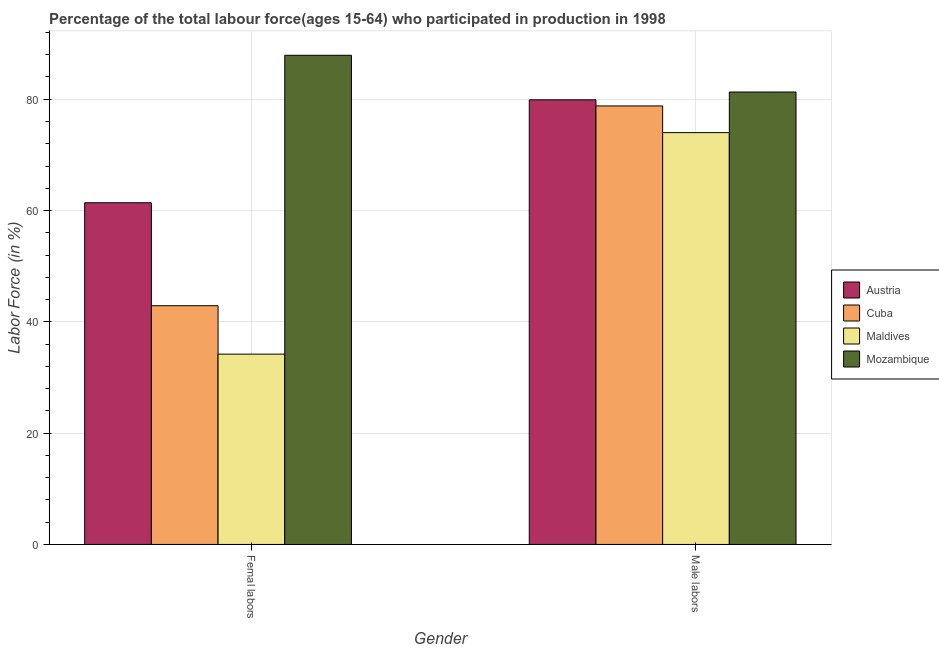Are the number of bars per tick equal to the number of legend labels?
Your response must be concise. Yes. How many bars are there on the 2nd tick from the right?
Your response must be concise. 4. What is the label of the 2nd group of bars from the left?
Offer a very short reply. Male labors. What is the percentage of female labor force in Maldives?
Provide a short and direct response. 34.2. Across all countries, what is the maximum percentage of male labour force?
Provide a short and direct response. 81.3. Across all countries, what is the minimum percentage of male labour force?
Your response must be concise. 74. In which country was the percentage of female labor force maximum?
Ensure brevity in your answer.  Mozambique. In which country was the percentage of female labor force minimum?
Provide a succinct answer. Maldives. What is the total percentage of male labour force in the graph?
Your answer should be compact. 314. What is the difference between the percentage of female labor force in Mozambique and that in Austria?
Ensure brevity in your answer.  26.5. What is the difference between the percentage of male labour force in Mozambique and the percentage of female labor force in Austria?
Make the answer very short. 19.9. What is the average percentage of female labor force per country?
Ensure brevity in your answer.  56.6. What is the difference between the percentage of male labour force and percentage of female labor force in Austria?
Keep it short and to the point. 18.5. In how many countries, is the percentage of male labour force greater than 36 %?
Offer a terse response. 4. What is the ratio of the percentage of male labour force in Mozambique to that in Austria?
Give a very brief answer. 1.02. In how many countries, is the percentage of male labour force greater than the average percentage of male labour force taken over all countries?
Provide a succinct answer. 3. What does the 2nd bar from the left in Male labors represents?
Keep it short and to the point. Cuba. What does the 2nd bar from the right in Femal labors represents?
Provide a succinct answer. Maldives. How many bars are there?
Your answer should be compact. 8. Are all the bars in the graph horizontal?
Your response must be concise. No. What is the difference between two consecutive major ticks on the Y-axis?
Offer a very short reply. 20. Does the graph contain any zero values?
Provide a short and direct response. No. Where does the legend appear in the graph?
Keep it short and to the point. Center right. How are the legend labels stacked?
Your answer should be compact. Vertical. What is the title of the graph?
Your answer should be compact. Percentage of the total labour force(ages 15-64) who participated in production in 1998. Does "Madagascar" appear as one of the legend labels in the graph?
Your response must be concise. No. What is the label or title of the X-axis?
Offer a terse response. Gender. What is the Labor Force (in %) of Austria in Femal labors?
Make the answer very short. 61.4. What is the Labor Force (in %) of Cuba in Femal labors?
Provide a succinct answer. 42.9. What is the Labor Force (in %) in Maldives in Femal labors?
Give a very brief answer. 34.2. What is the Labor Force (in %) of Mozambique in Femal labors?
Provide a succinct answer. 87.9. What is the Labor Force (in %) of Austria in Male labors?
Give a very brief answer. 79.9. What is the Labor Force (in %) of Cuba in Male labors?
Offer a very short reply. 78.8. What is the Labor Force (in %) of Mozambique in Male labors?
Provide a short and direct response. 81.3. Across all Gender, what is the maximum Labor Force (in %) of Austria?
Provide a short and direct response. 79.9. Across all Gender, what is the maximum Labor Force (in %) in Cuba?
Provide a succinct answer. 78.8. Across all Gender, what is the maximum Labor Force (in %) of Maldives?
Keep it short and to the point. 74. Across all Gender, what is the maximum Labor Force (in %) of Mozambique?
Provide a short and direct response. 87.9. Across all Gender, what is the minimum Labor Force (in %) of Austria?
Your answer should be very brief. 61.4. Across all Gender, what is the minimum Labor Force (in %) in Cuba?
Your response must be concise. 42.9. Across all Gender, what is the minimum Labor Force (in %) of Maldives?
Ensure brevity in your answer.  34.2. Across all Gender, what is the minimum Labor Force (in %) in Mozambique?
Your answer should be compact. 81.3. What is the total Labor Force (in %) in Austria in the graph?
Give a very brief answer. 141.3. What is the total Labor Force (in %) in Cuba in the graph?
Your answer should be compact. 121.7. What is the total Labor Force (in %) in Maldives in the graph?
Provide a short and direct response. 108.2. What is the total Labor Force (in %) of Mozambique in the graph?
Provide a short and direct response. 169.2. What is the difference between the Labor Force (in %) in Austria in Femal labors and that in Male labors?
Give a very brief answer. -18.5. What is the difference between the Labor Force (in %) in Cuba in Femal labors and that in Male labors?
Offer a terse response. -35.9. What is the difference between the Labor Force (in %) of Maldives in Femal labors and that in Male labors?
Provide a succinct answer. -39.8. What is the difference between the Labor Force (in %) of Mozambique in Femal labors and that in Male labors?
Offer a very short reply. 6.6. What is the difference between the Labor Force (in %) in Austria in Femal labors and the Labor Force (in %) in Cuba in Male labors?
Your response must be concise. -17.4. What is the difference between the Labor Force (in %) of Austria in Femal labors and the Labor Force (in %) of Mozambique in Male labors?
Your answer should be very brief. -19.9. What is the difference between the Labor Force (in %) in Cuba in Femal labors and the Labor Force (in %) in Maldives in Male labors?
Provide a short and direct response. -31.1. What is the difference between the Labor Force (in %) in Cuba in Femal labors and the Labor Force (in %) in Mozambique in Male labors?
Give a very brief answer. -38.4. What is the difference between the Labor Force (in %) of Maldives in Femal labors and the Labor Force (in %) of Mozambique in Male labors?
Offer a terse response. -47.1. What is the average Labor Force (in %) in Austria per Gender?
Keep it short and to the point. 70.65. What is the average Labor Force (in %) of Cuba per Gender?
Offer a terse response. 60.85. What is the average Labor Force (in %) in Maldives per Gender?
Give a very brief answer. 54.1. What is the average Labor Force (in %) of Mozambique per Gender?
Offer a terse response. 84.6. What is the difference between the Labor Force (in %) of Austria and Labor Force (in %) of Cuba in Femal labors?
Your answer should be compact. 18.5. What is the difference between the Labor Force (in %) of Austria and Labor Force (in %) of Maldives in Femal labors?
Give a very brief answer. 27.2. What is the difference between the Labor Force (in %) of Austria and Labor Force (in %) of Mozambique in Femal labors?
Give a very brief answer. -26.5. What is the difference between the Labor Force (in %) of Cuba and Labor Force (in %) of Maldives in Femal labors?
Offer a terse response. 8.7. What is the difference between the Labor Force (in %) of Cuba and Labor Force (in %) of Mozambique in Femal labors?
Offer a very short reply. -45. What is the difference between the Labor Force (in %) in Maldives and Labor Force (in %) in Mozambique in Femal labors?
Ensure brevity in your answer.  -53.7. What is the difference between the Labor Force (in %) of Cuba and Labor Force (in %) of Mozambique in Male labors?
Keep it short and to the point. -2.5. What is the difference between the Labor Force (in %) in Maldives and Labor Force (in %) in Mozambique in Male labors?
Provide a short and direct response. -7.3. What is the ratio of the Labor Force (in %) of Austria in Femal labors to that in Male labors?
Keep it short and to the point. 0.77. What is the ratio of the Labor Force (in %) in Cuba in Femal labors to that in Male labors?
Your answer should be compact. 0.54. What is the ratio of the Labor Force (in %) in Maldives in Femal labors to that in Male labors?
Offer a terse response. 0.46. What is the ratio of the Labor Force (in %) of Mozambique in Femal labors to that in Male labors?
Provide a succinct answer. 1.08. What is the difference between the highest and the second highest Labor Force (in %) in Austria?
Make the answer very short. 18.5. What is the difference between the highest and the second highest Labor Force (in %) of Cuba?
Offer a terse response. 35.9. What is the difference between the highest and the second highest Labor Force (in %) in Maldives?
Your answer should be very brief. 39.8. What is the difference between the highest and the lowest Labor Force (in %) in Cuba?
Provide a short and direct response. 35.9. What is the difference between the highest and the lowest Labor Force (in %) in Maldives?
Make the answer very short. 39.8. What is the difference between the highest and the lowest Labor Force (in %) of Mozambique?
Ensure brevity in your answer.  6.6. 